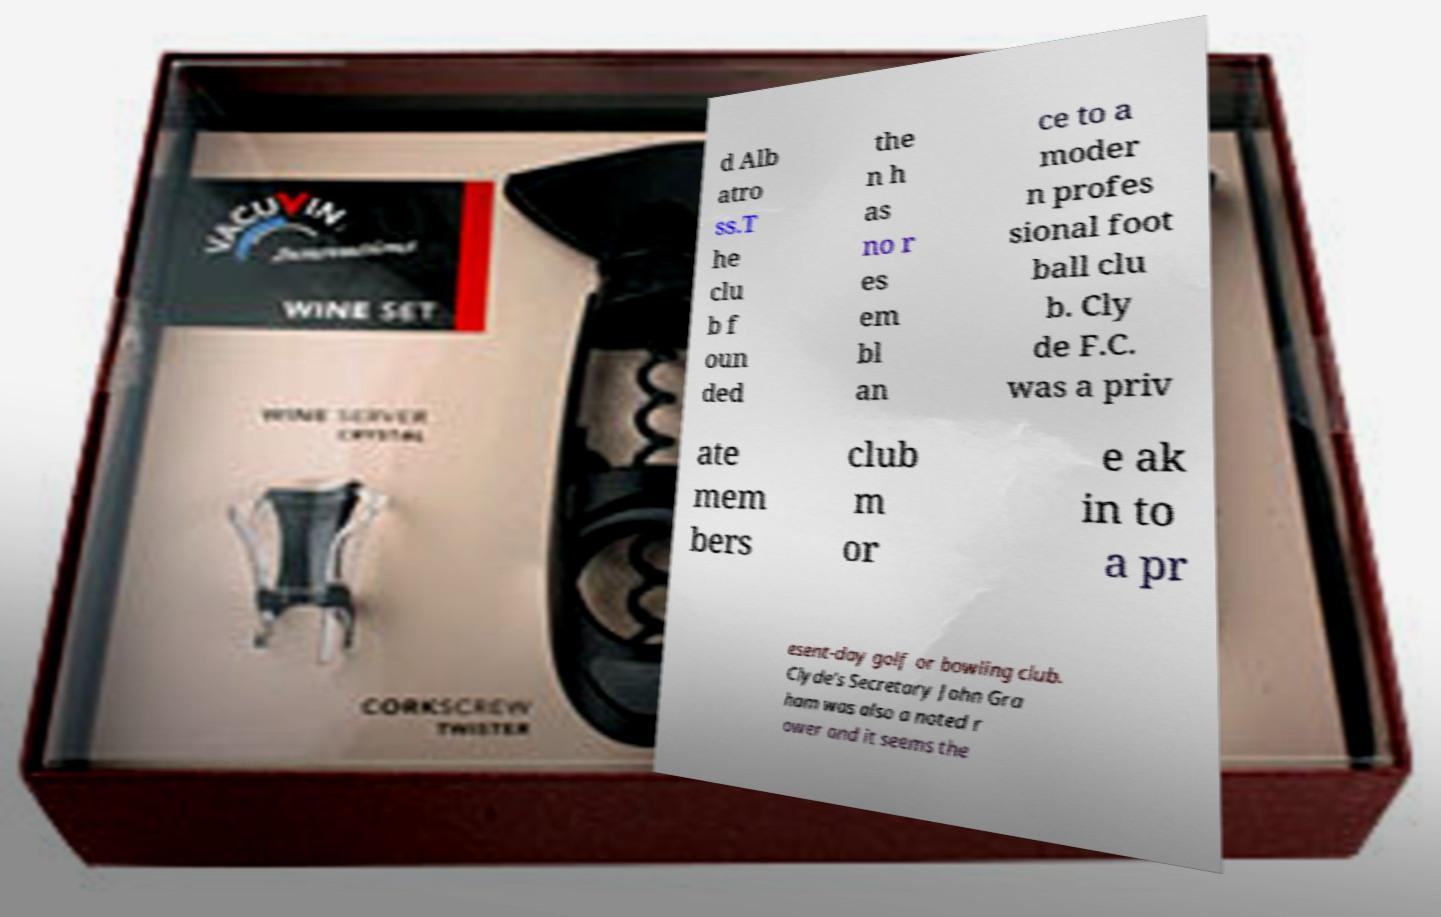Please read and relay the text visible in this image. What does it say? d Alb atro ss.T he clu b f oun ded the n h as no r es em bl an ce to a moder n profes sional foot ball clu b. Cly de F.C. was a priv ate mem bers club m or e ak in to a pr esent-day golf or bowling club. Clyde's Secretary John Gra ham was also a noted r ower and it seems the 